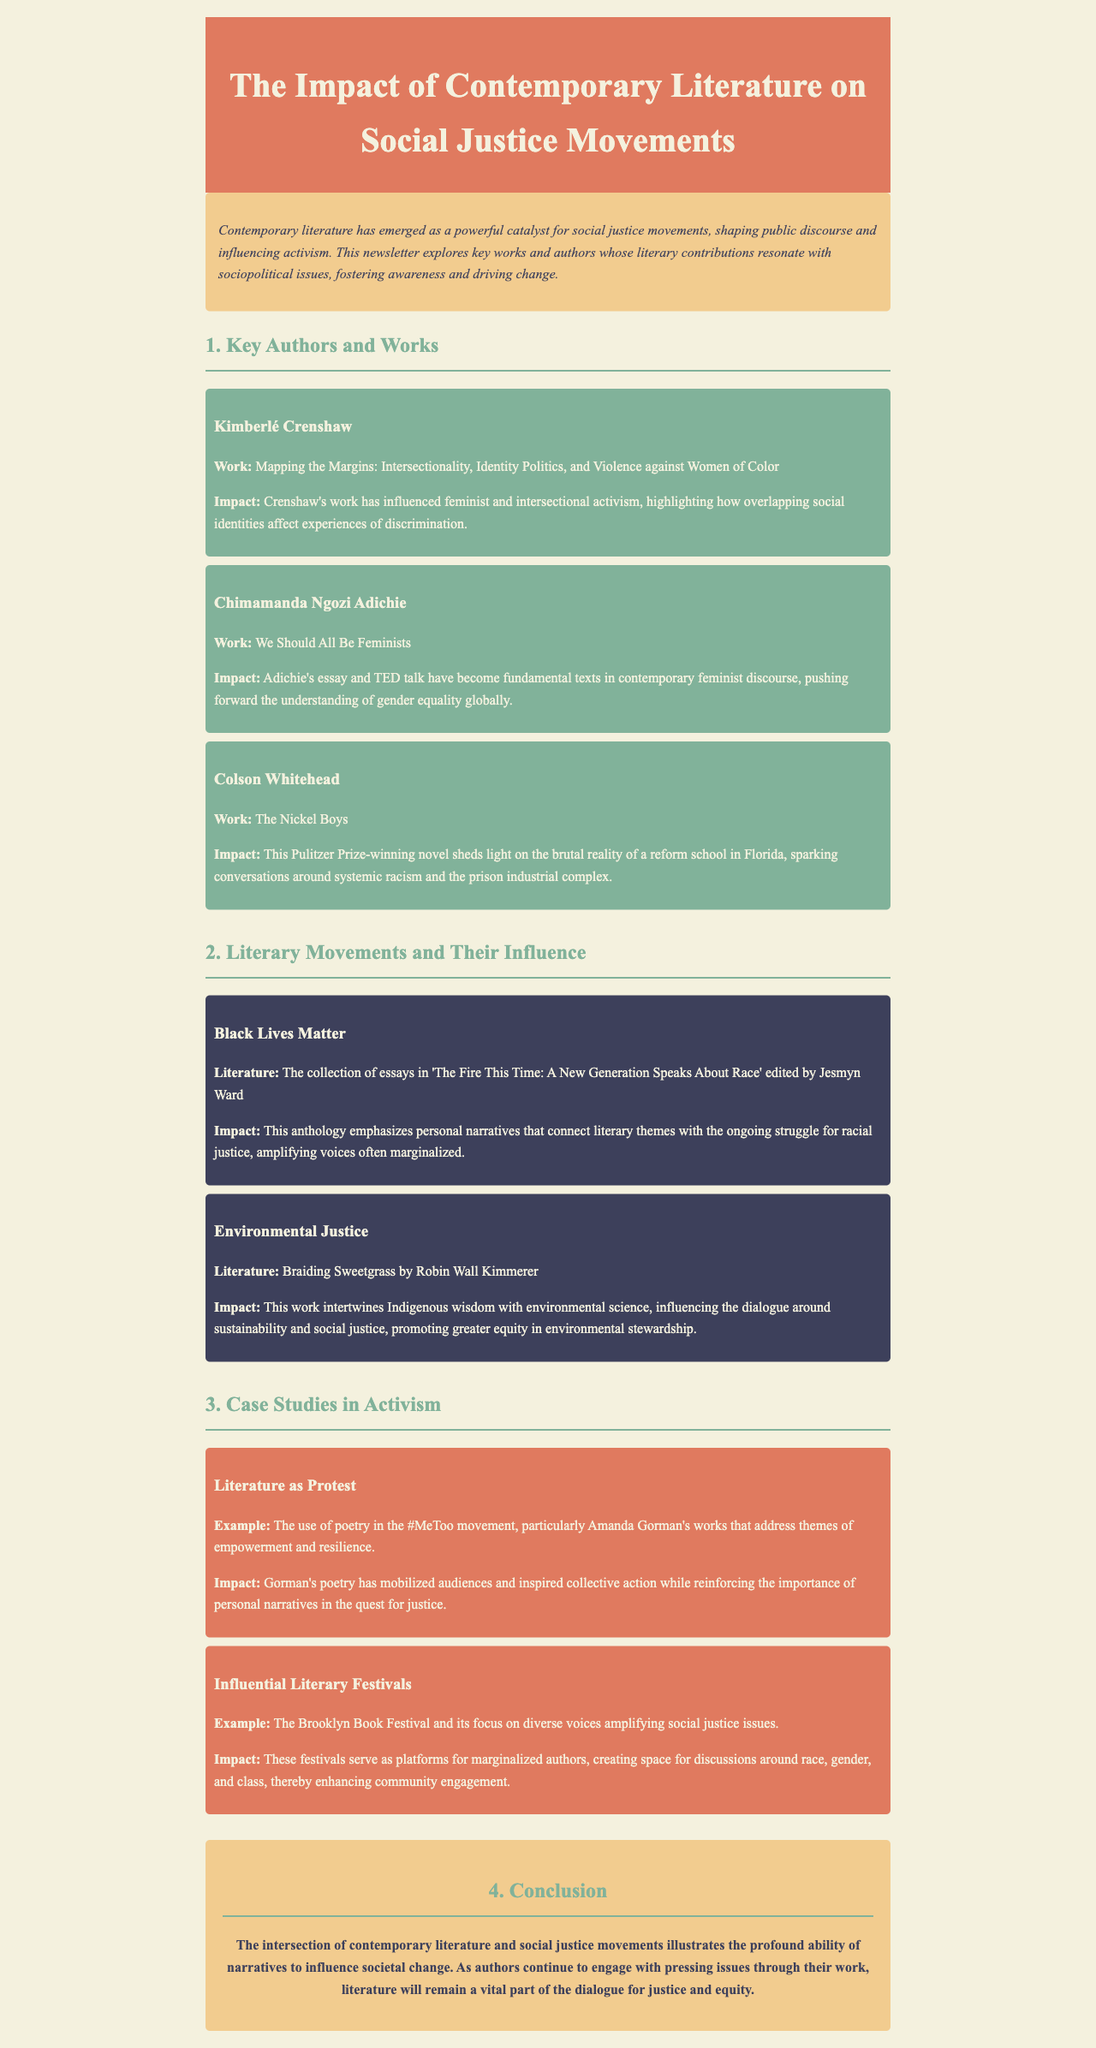What is the title of the newsletter? The title of the newsletter is provided in the header section, which states the focus on literature and social justice movements.
Answer: The Impact of Contemporary Literature on Social Justice Movements Who is the author of "Mapping the Margins"? The document lists Kimberlé Crenshaw as the author of "Mapping the Margins".
Answer: Kimberlé Crenshaw What literary work is associated with the Black Lives Matter movement? The document mentions the collection of essays titled "The Fire This Time: A New Generation Speaks About Race" related to the Black Lives Matter movement.
Answer: The Fire This Time: A New Generation Speaks About Race How has Adichie's work impacted feminism? The newsletter indicates that Adichie's work has become a fundamental text in contemporary feminist discourse.
Answer: Fundamental text What genre does Amanda Gorman's work belong to in the context of the #MeToo movement? The document specifies that poetry is the genre of Amanda Gorman's works addressing themes of empowerment and resilience.
Answer: Poetry What is the main focus of the Brooklyn Book Festival? The document explains that the focus of the Brooklyn Book Festival is on diverse voices amplifying social justice issues.
Answer: Diverse voices What literary work intertwines Indigenous wisdom with environmental science? The newsletter highlights "Braiding Sweetgrass" by Robin Wall Kimmerer as a work integrating Indigenous wisdom and environmental science.
Answer: Braiding Sweetgrass What is the overall conclusion made in the newsletter? The conclusion section emphasizes the profound ability of narratives to influence societal change through literature.
Answer: Influence societal change 